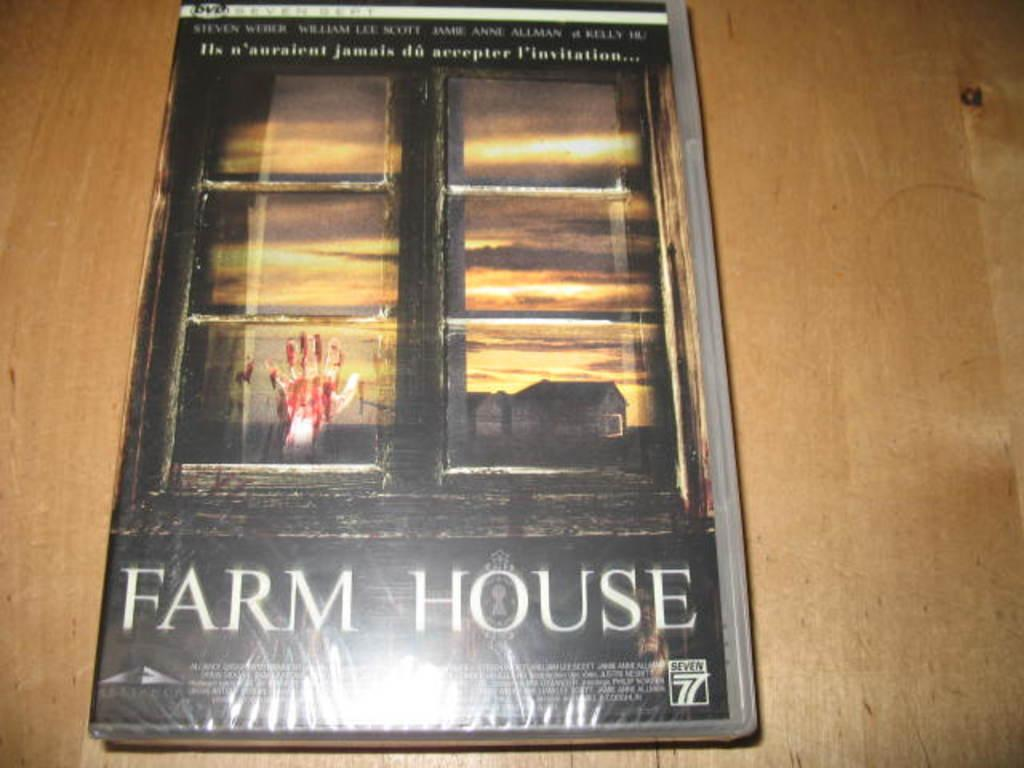Provide a one-sentence caption for the provided image. A book covered in clear plastic has the title Farm House and the image of a bloody hand on a window pane. 